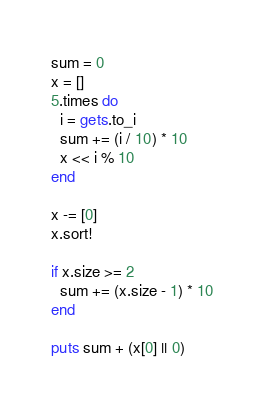Convert code to text. <code><loc_0><loc_0><loc_500><loc_500><_Ruby_>sum = 0
x = []
5.times do
  i = gets.to_i
  sum += (i / 10) * 10
  x << i % 10
end

x -= [0]
x.sort!

if x.size >= 2
  sum += (x.size - 1) * 10
end

puts sum + (x[0] || 0)</code> 